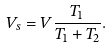<formula> <loc_0><loc_0><loc_500><loc_500>V _ { s } = V \frac { T _ { 1 } } { T _ { 1 } + T _ { 2 } } .</formula> 